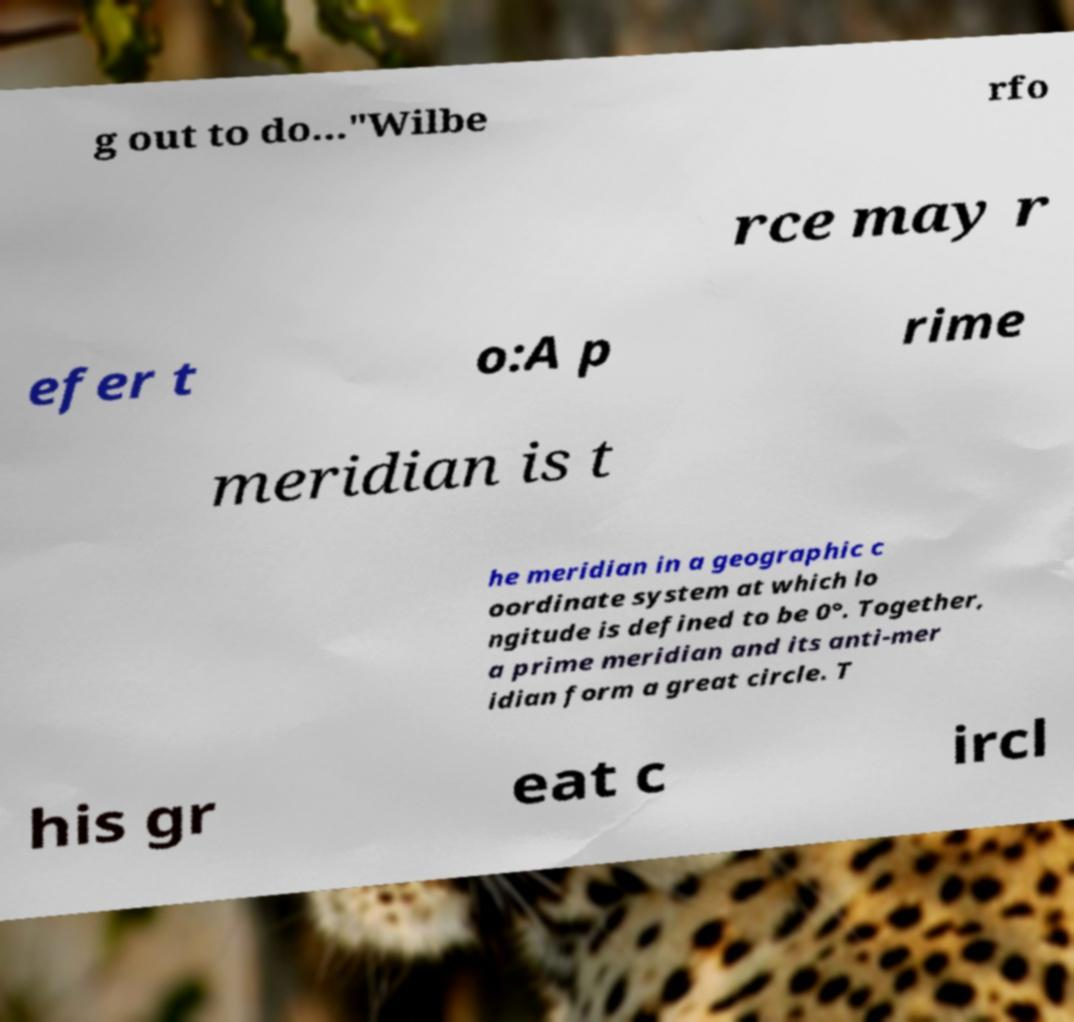There's text embedded in this image that I need extracted. Can you transcribe it verbatim? g out to do..."Wilbe rfo rce may r efer t o:A p rime meridian is t he meridian in a geographic c oordinate system at which lo ngitude is defined to be 0°. Together, a prime meridian and its anti-mer idian form a great circle. T his gr eat c ircl 